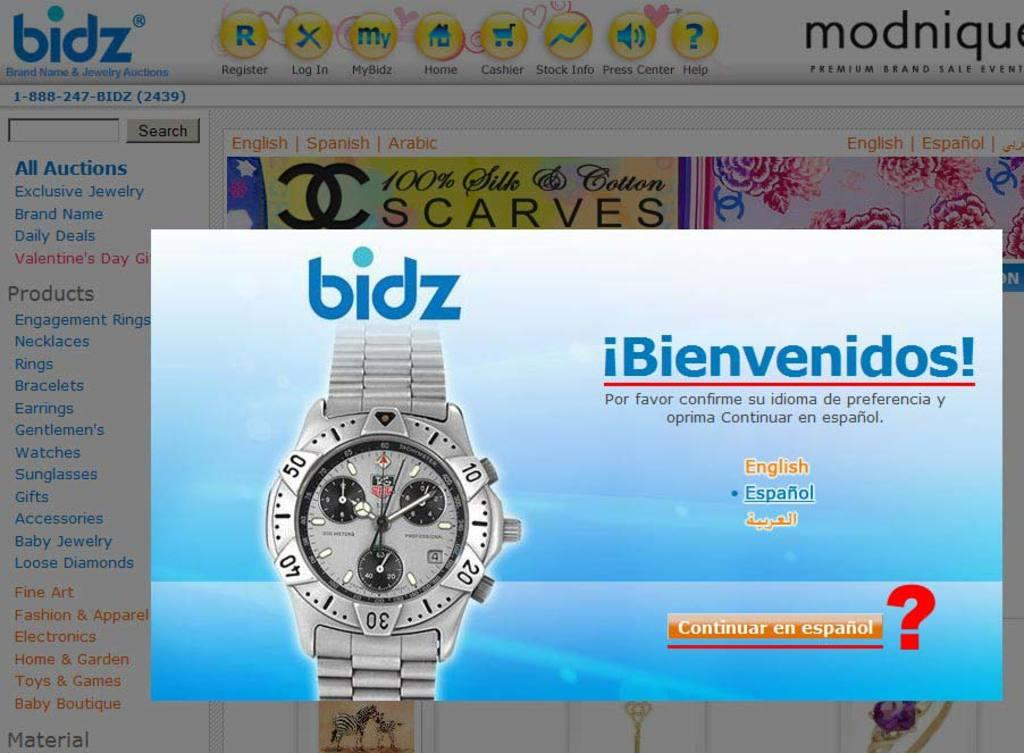<image>
Share a concise interpretation of the image provided. An advertisement for bidz says Bienvenidos and is a popup in front of the bidz website in the background. 